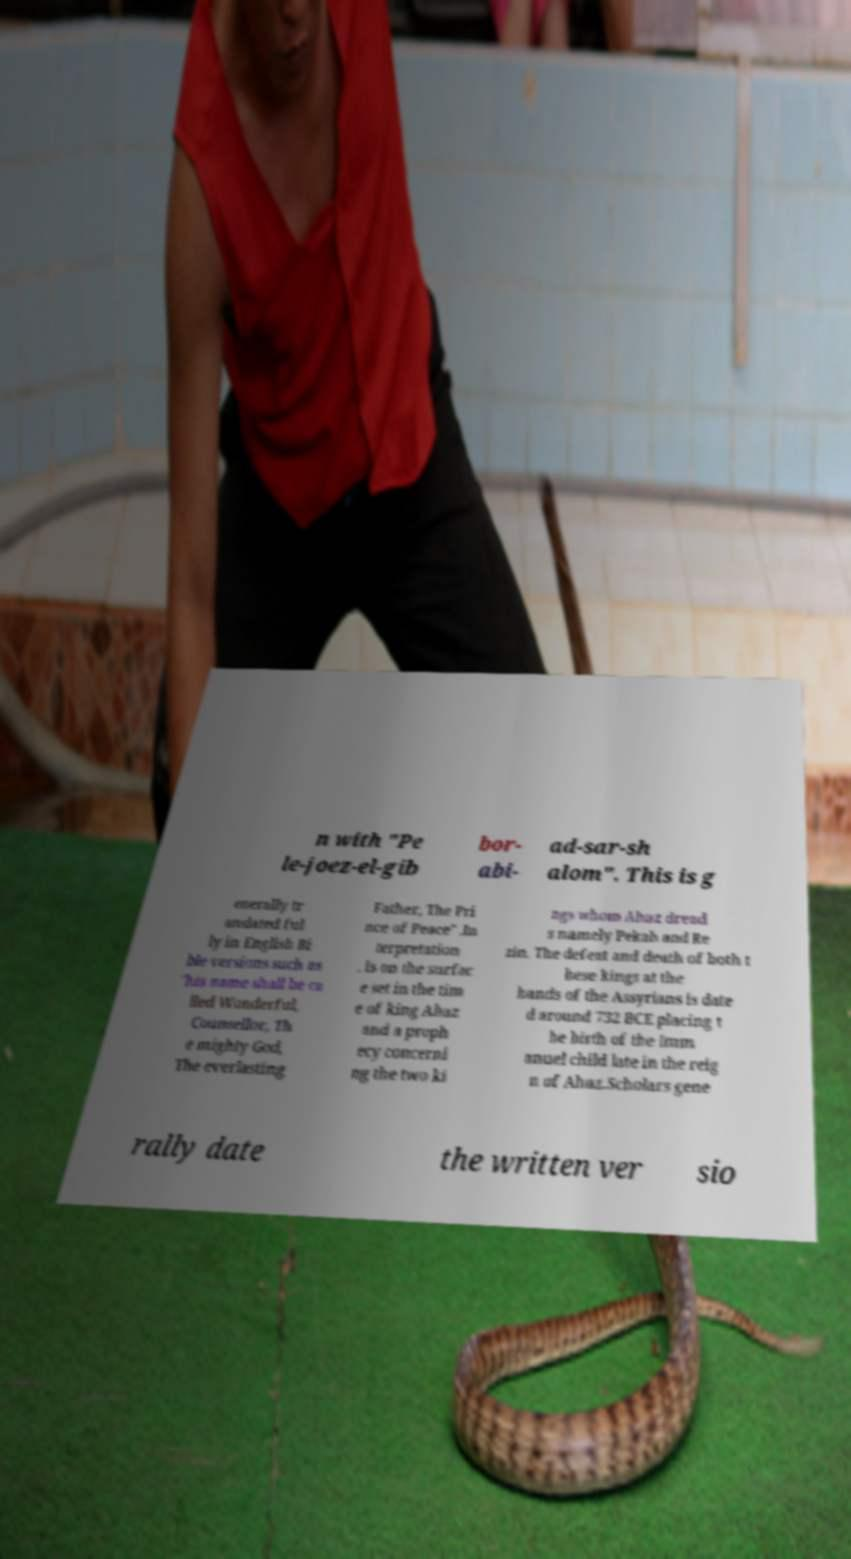What messages or text are displayed in this image? I need them in a readable, typed format. n with "Pe le-joez-el-gib bor- abi- ad-sar-sh alom". This is g enerally tr anslated ful ly in English Bi ble versions such as "his name shall be ca lled Wonderful, Counsellor, Th e mighty God, The everlasting Father, The Pri nce of Peace" .In terpretation . is on the surfac e set in the tim e of king Ahaz and a proph ecy concerni ng the two ki ngs whom Ahaz dread s namely Pekah and Re zin. The defeat and death of both t hese kings at the hands of the Assyrians is date d around 732 BCE placing t he birth of the Imm anuel child late in the reig n of Ahaz.Scholars gene rally date the written ver sio 